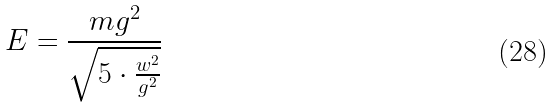Convert formula to latex. <formula><loc_0><loc_0><loc_500><loc_500>E = \frac { m g ^ { 2 } } { \sqrt { 5 \cdot \frac { w ^ { 2 } } { g ^ { 2 } } } }</formula> 